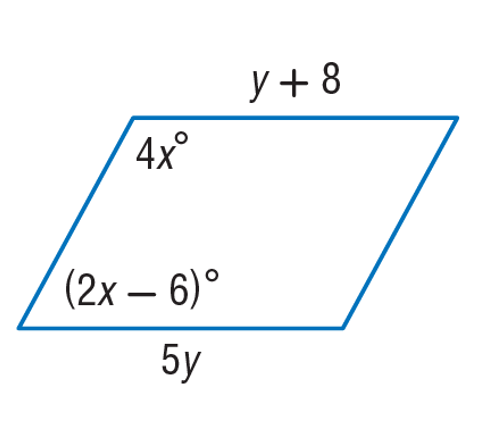Question: Find y in the given parallelogram.
Choices:
A. 2
B. 10
C. 31
D. 149
Answer with the letter. Answer: A 